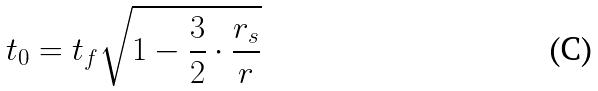Convert formula to latex. <formula><loc_0><loc_0><loc_500><loc_500>t _ { 0 } = t _ { f } \sqrt { 1 - \frac { 3 } { 2 } \cdot \frac { r _ { s } } { r } }</formula> 